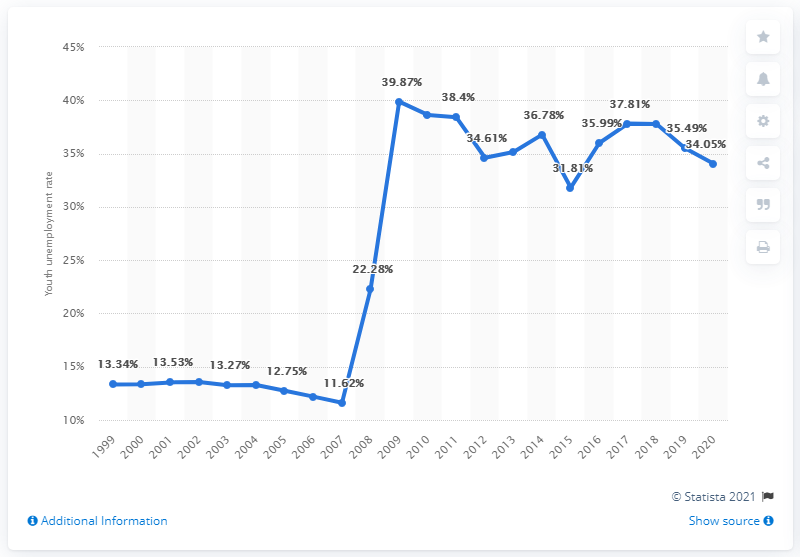Point out several critical features in this image. In 2020, the youth unemployment rate in Armenia was 34.05%. 